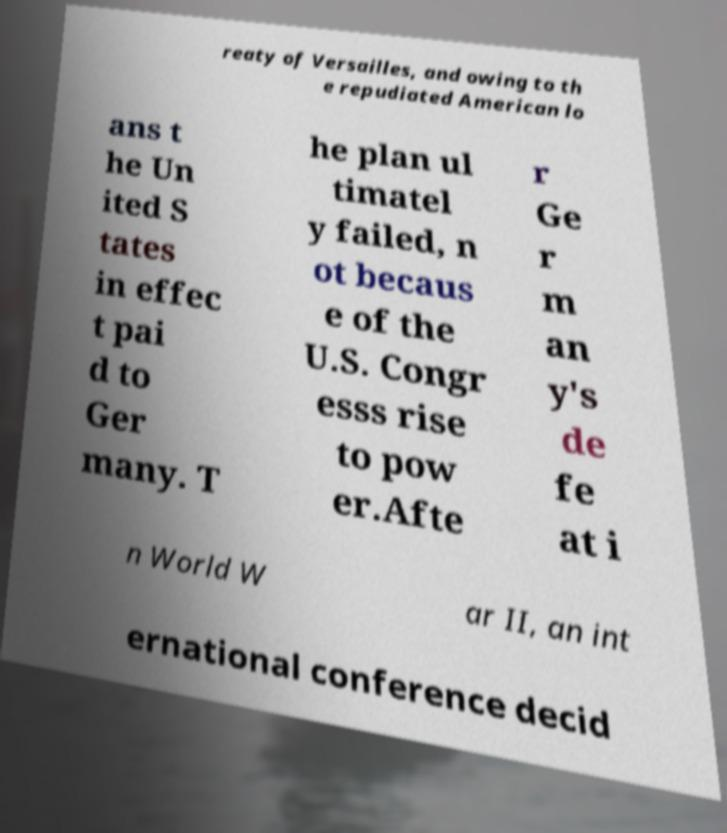Could you assist in decoding the text presented in this image and type it out clearly? reaty of Versailles, and owing to th e repudiated American lo ans t he Un ited S tates in effec t pai d to Ger many. T he plan ul timatel y failed, n ot becaus e of the U.S. Congr esss rise to pow er.Afte r Ge r m an y's de fe at i n World W ar II, an int ernational conference decid 